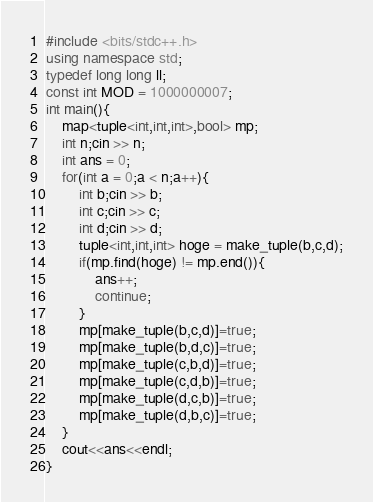Convert code to text. <code><loc_0><loc_0><loc_500><loc_500><_C++_>#include <bits/stdc++.h>
using namespace std;
typedef long long ll;
const int MOD = 1000000007;
int main(){
    map<tuple<int,int,int>,bool> mp;
    int n;cin >> n;
    int ans = 0;
    for(int a = 0;a < n;a++){
        int b;cin >> b;
        int c;cin >> c;
        int d;cin >> d;
        tuple<int,int,int> hoge = make_tuple(b,c,d);
        if(mp.find(hoge) != mp.end()){
            ans++;
            continue;
        }
        mp[make_tuple(b,c,d)]=true;
        mp[make_tuple(b,d,c)]=true;
        mp[make_tuple(c,b,d)]=true;
        mp[make_tuple(c,d,b)]=true;
        mp[make_tuple(d,c,b)]=true;
        mp[make_tuple(d,b,c)]=true;
    }
    cout<<ans<<endl;
}

</code> 